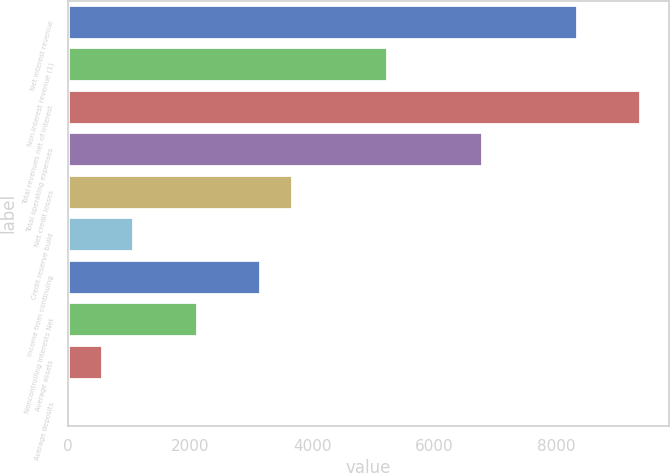<chart> <loc_0><loc_0><loc_500><loc_500><bar_chart><fcel>Net interest revenue<fcel>Non-interest revenue (1)<fcel>Total revenues net of interest<fcel>Total operating expenses<fcel>Net credit losses<fcel>Credit reserve build<fcel>Income from continuing<fcel>Noncontrolling interests Net<fcel>Average assets<fcel>Average deposits<nl><fcel>8338.76<fcel>5222<fcel>9377.68<fcel>6780.38<fcel>3663.62<fcel>1066.32<fcel>3144.16<fcel>2105.24<fcel>546.86<fcel>27.4<nl></chart> 